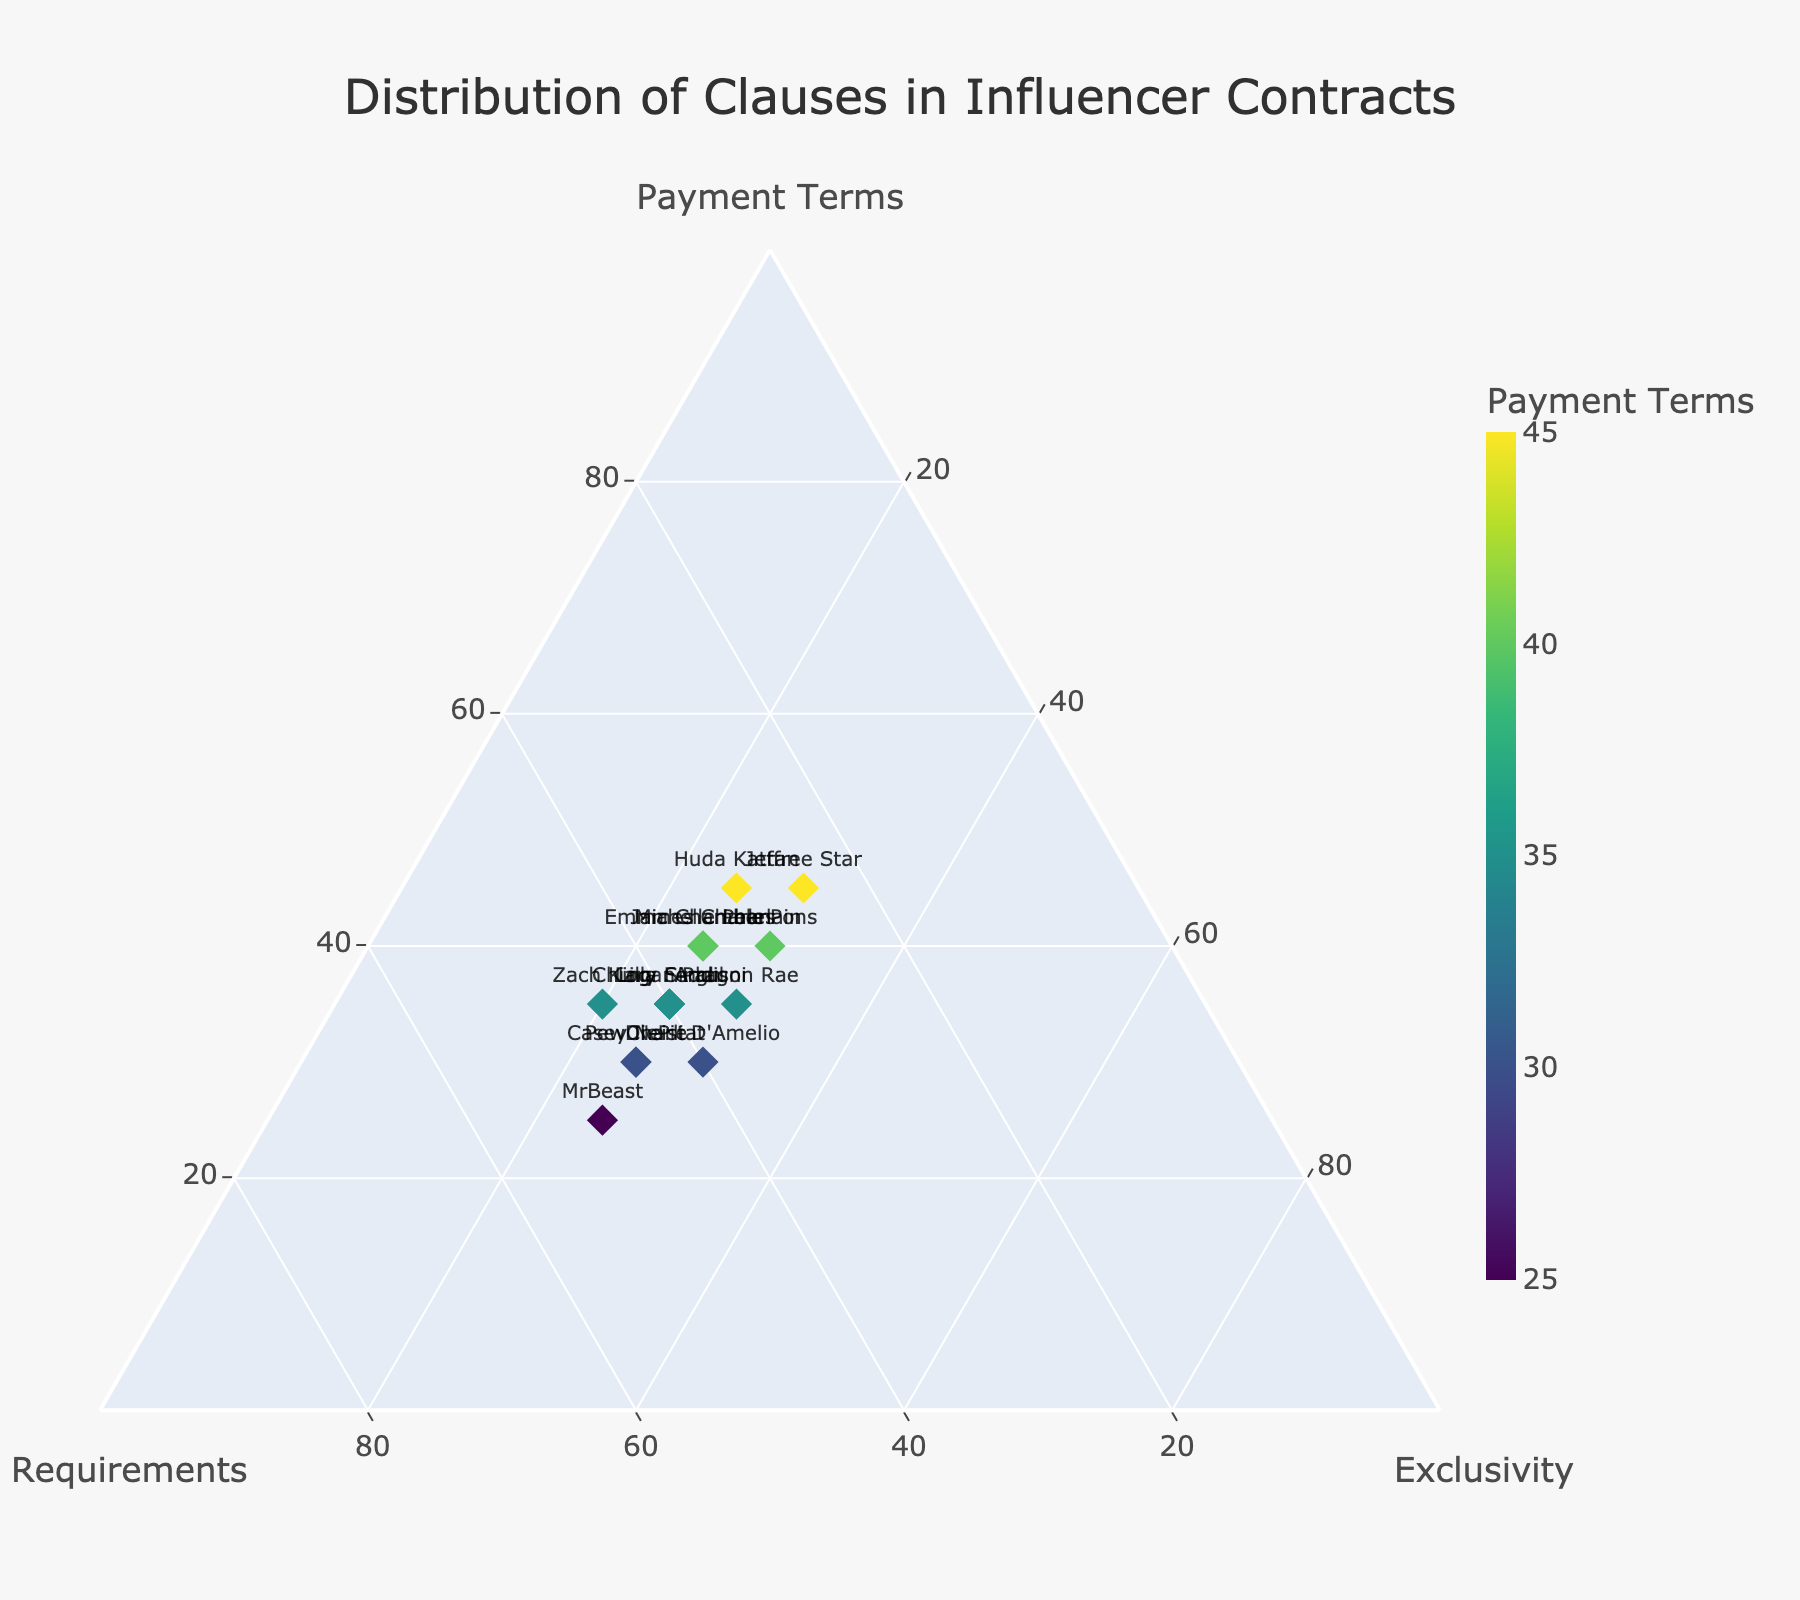What's the title of the figure? The title of a figure is typically displayed prominently at the top of the plot. In this case, the title is set to be “Distribution of Clauses in Influencer Contracts.”
Answer: Distribution of Clauses in Influencer Contracts How many influencers have their data points plotted in the ternary plot? To find the number of influencers, we count the number of unique names labeled on the plot. According to the data provided, there are 15 influencers.
Answer: 15 Which influencer has the highest value for Payment Terms? By examining the values plotted along the Payment Terms axis, we see that Huda Kattan and Jeffree Star each have the highest value of 45.
Answer: Huda Kattan and Jeffree Star Which influencer has the lowest value for Payment Terms? By inspecting the values along the Payment Terms axis, MrBeast possesses the lowest value with a score of 25.
Answer: MrBeast How many influencers have an Exclusivity value of 25? By counting the data points along the Exclusivity axis that have a value of 25, we observe that there are 10 influencers.
Answer: 10 Who are the influencers with an equal distribution among the three clauses? To find influencers with approximately equal values among Payment Terms, Content Requirements, and Exclusivity, we need to look for values around 33%. No influencer has values exactly equal, but Addison Rae (35, 35, 30) and Lele Pons (40, 30, 30) come close.
Answer: Addison Rae and Lele Pons Which influencer has the highest value for Content Requirements, and what is that value? By scanning the Content Requirements axis, MrBeast has the highest value, which is 50.
Answer: MrBeast, 50 Who are the influencers with an Exclusivity value of 30? By checking the labels next to the points plotted at the 30 mark on the Exclusivity axis, we identify Charli D'Amelio, Addison Rae, Lele Pons, and Jeffree Star.
Answer: Charli D'Amelio, Addison Rae, Lele Pons, and Jeffree Star Compare the payment terms of Emma Chamberlain and Logan Paul. Who has a higher value? Examining the values on the Payment Terms axis, Emma Chamberlain has a value of 40, while Logan Paul has a value of 35. Thus, Emma Chamberlain has a higher value.
Answer: Emma Chamberlain Which clause seems to have the least variation among influencers? By examining the plot visually, the Exclusivity axis has values mostly clustered around 25-30, indicating that there is the least variation in Exclusivity compared to Payment Terms and Content Requirements.
Answer: Exclusivity 